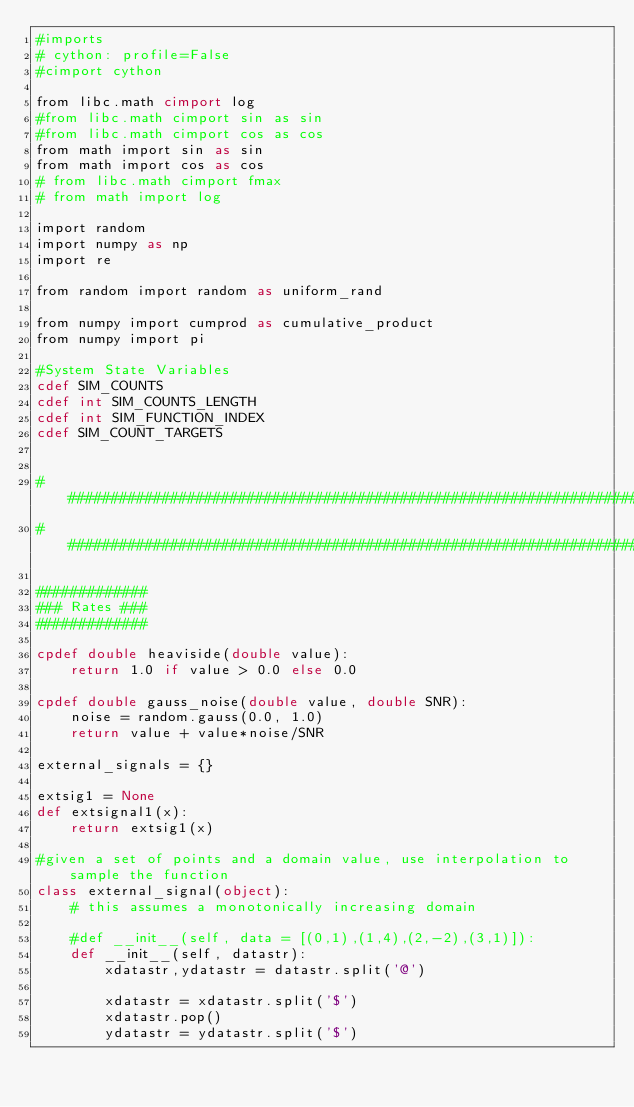<code> <loc_0><loc_0><loc_500><loc_500><_Cython_>#imports
# cython: profile=False
#cimport cython

from libc.math cimport log
#from libc.math cimport sin as sin
#from libc.math cimport cos as cos
from math import sin as sin
from math import cos as cos
# from libc.math cimport fmax
# from math import log

import random
import numpy as np
import re

from random import random as uniform_rand

from numpy import cumprod as cumulative_product
from numpy import pi

#System State Variables
cdef SIM_COUNTS
cdef int SIM_COUNTS_LENGTH
cdef int SIM_FUNCTION_INDEX
cdef SIM_COUNT_TARGETS


############################################################################
############################################################################

#############
### Rates ###
#############

cpdef double heaviside(double value):
    return 1.0 if value > 0.0 else 0.0

cpdef double gauss_noise(double value, double SNR):
    noise = random.gauss(0.0, 1.0)
    return value + value*noise/SNR

external_signals = {}

extsig1 = None
def extsignal1(x):
    return extsig1(x)

#given a set of points and a domain value, use interpolation to sample the function
class external_signal(object):
    # this assumes a monotonically increasing domain

    #def __init__(self, data = [(0,1),(1,4),(2,-2),(3,1)]):
    def __init__(self, datastr):
        xdatastr,ydatastr = datastr.split('@')

        xdatastr = xdatastr.split('$')
        xdatastr.pop()
        ydatastr = ydatastr.split('$')</code> 